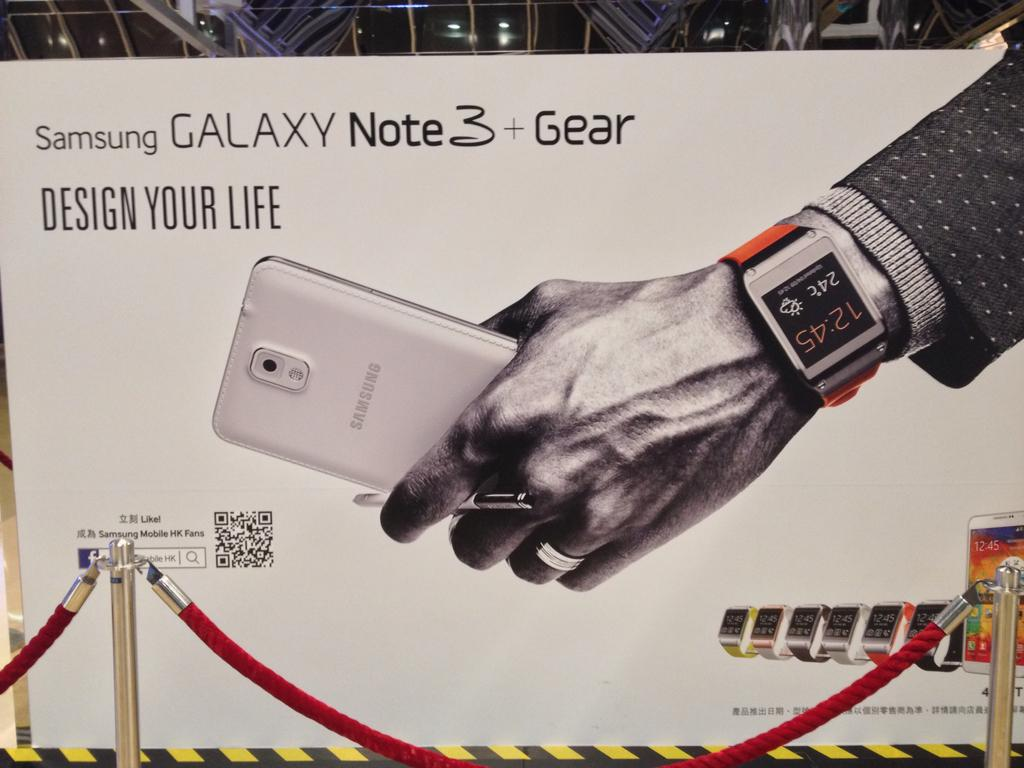<image>
Describe the image concisely. A box for the Samsung Galaxy Note 3 displays a white version of the phone. 